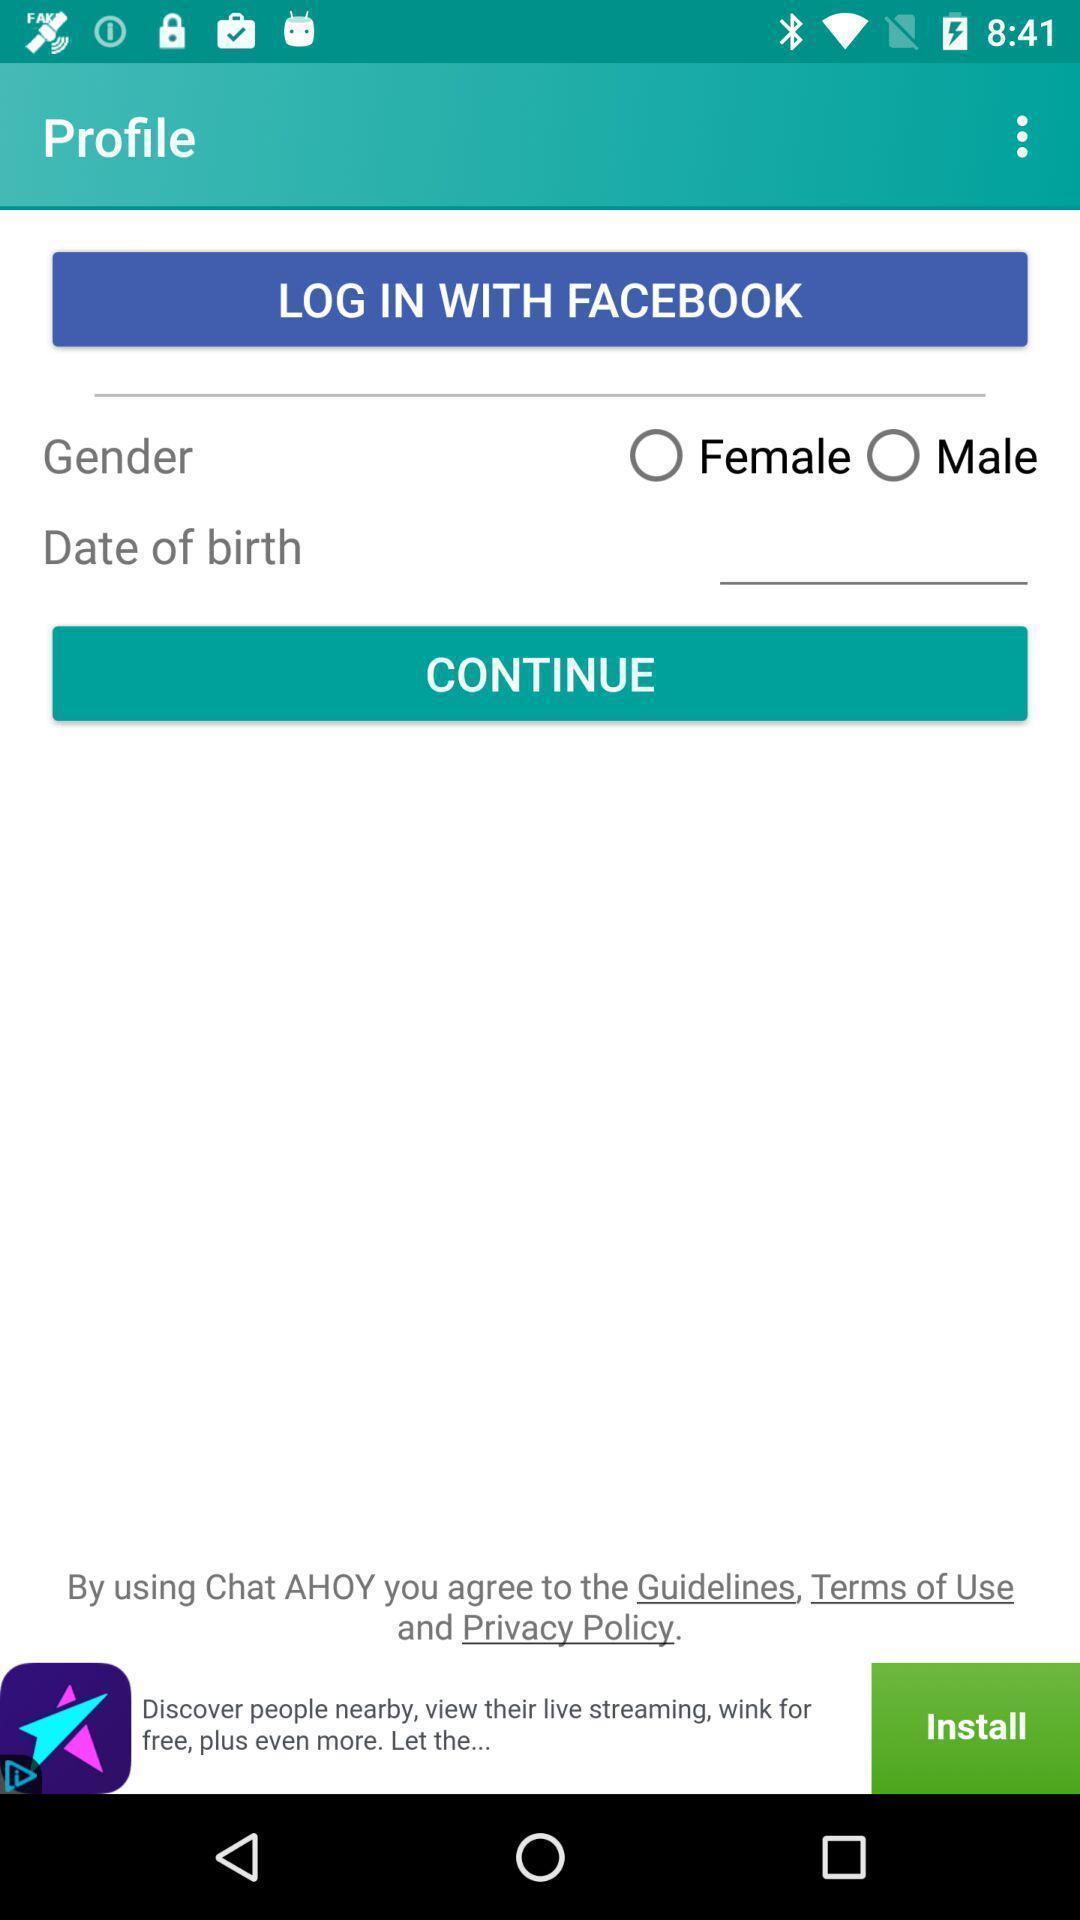What can you discern from this picture? Profile details in the app. 